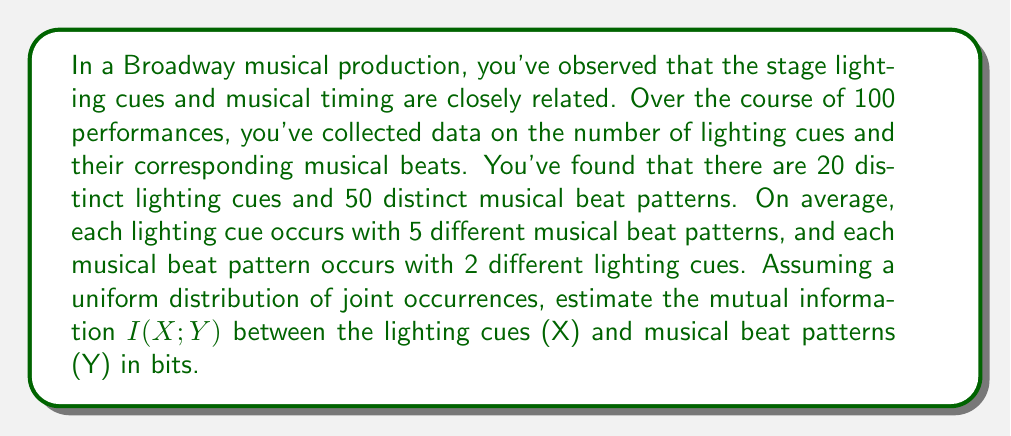Solve this math problem. To solve this problem, we'll follow these steps:

1) First, let's define our variables:
   $X$: Lighting cues
   $Y$: Musical beat patterns

2) We're given:
   $|X| = 20$ (number of distinct lighting cues)
   $|Y| = 50$ (number of distinct musical beat patterns)
   Each $x$ occurs with 5 different $y$ on average
   Each $y$ occurs with 2 different $x$ on average

3) The mutual information is defined as:

   $$I(X;Y) = H(X) + H(Y) - H(X,Y)$$

   where $H(X)$ and $H(Y)$ are the marginal entropies, and $H(X,Y)$ is the joint entropy.

4) Given the uniform distribution assumption:

   $$H(X) = \log_2(20)$$
   $$H(Y) = \log_2(50)$$

5) To find $H(X,Y)$, we need to calculate the number of joint occurrences:
   
   Number of joint occurrences = 20 * 5 = 50 * 2 = 100

   $$H(X,Y) = \log_2(100)$$

6) Now we can calculate the mutual information:

   $$I(X;Y) = \log_2(20) + \log_2(50) - \log_2(100)$$

7) Simplify:
   
   $$I(X;Y) = \log_2(20) + \log_2(50) - \log_2(100)$$
   $$= \log_2(20) + \log_2(50) - \log_2(50 * 2)$$
   $$= \log_2(20) + \log_2(50) - \log_2(50) - \log_2(2)$$
   $$= \log_2(20) - \log_2(2)$$
   $$= \log_2(10)$$

8) Calculate the final value:

   $$I(X;Y) = \log_2(10) \approx 3.32 \text{ bits}$$
Answer: The estimated mutual information between stage lighting cues and musical timing is approximately 3.32 bits. 